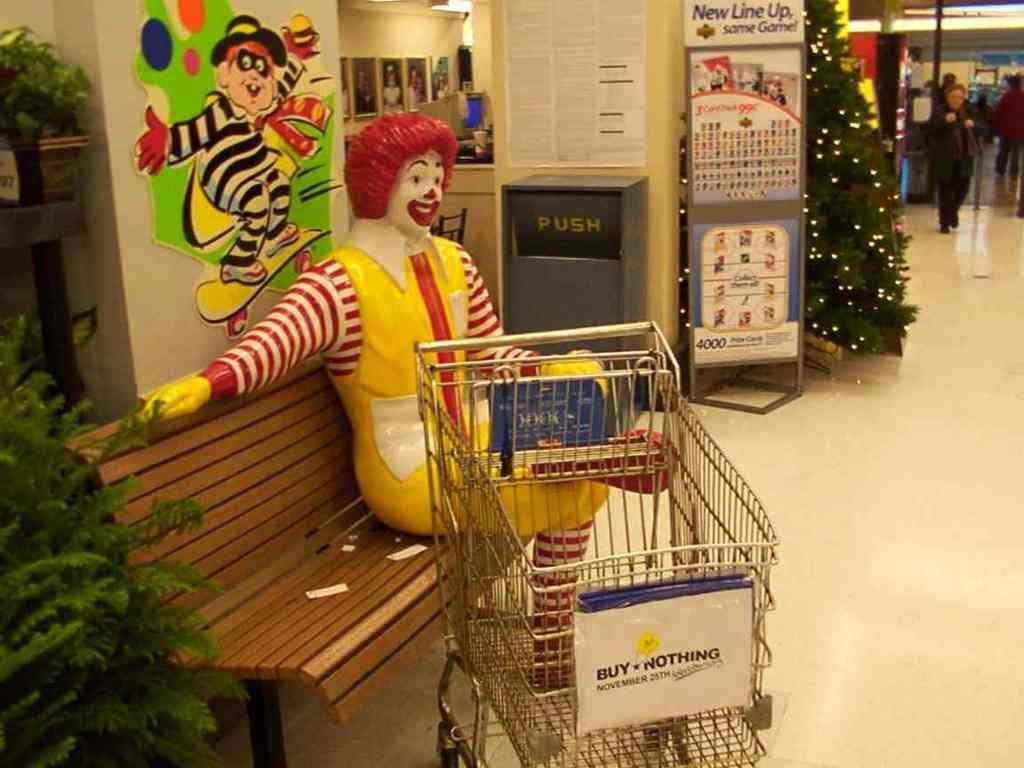How would you summarize this image in a sentence or two? In the image we can see there is a human statue sitting on the bench and there are plants. There is a painting on the wall and there are other people standing on the floor. There are photo frames on the wall. 